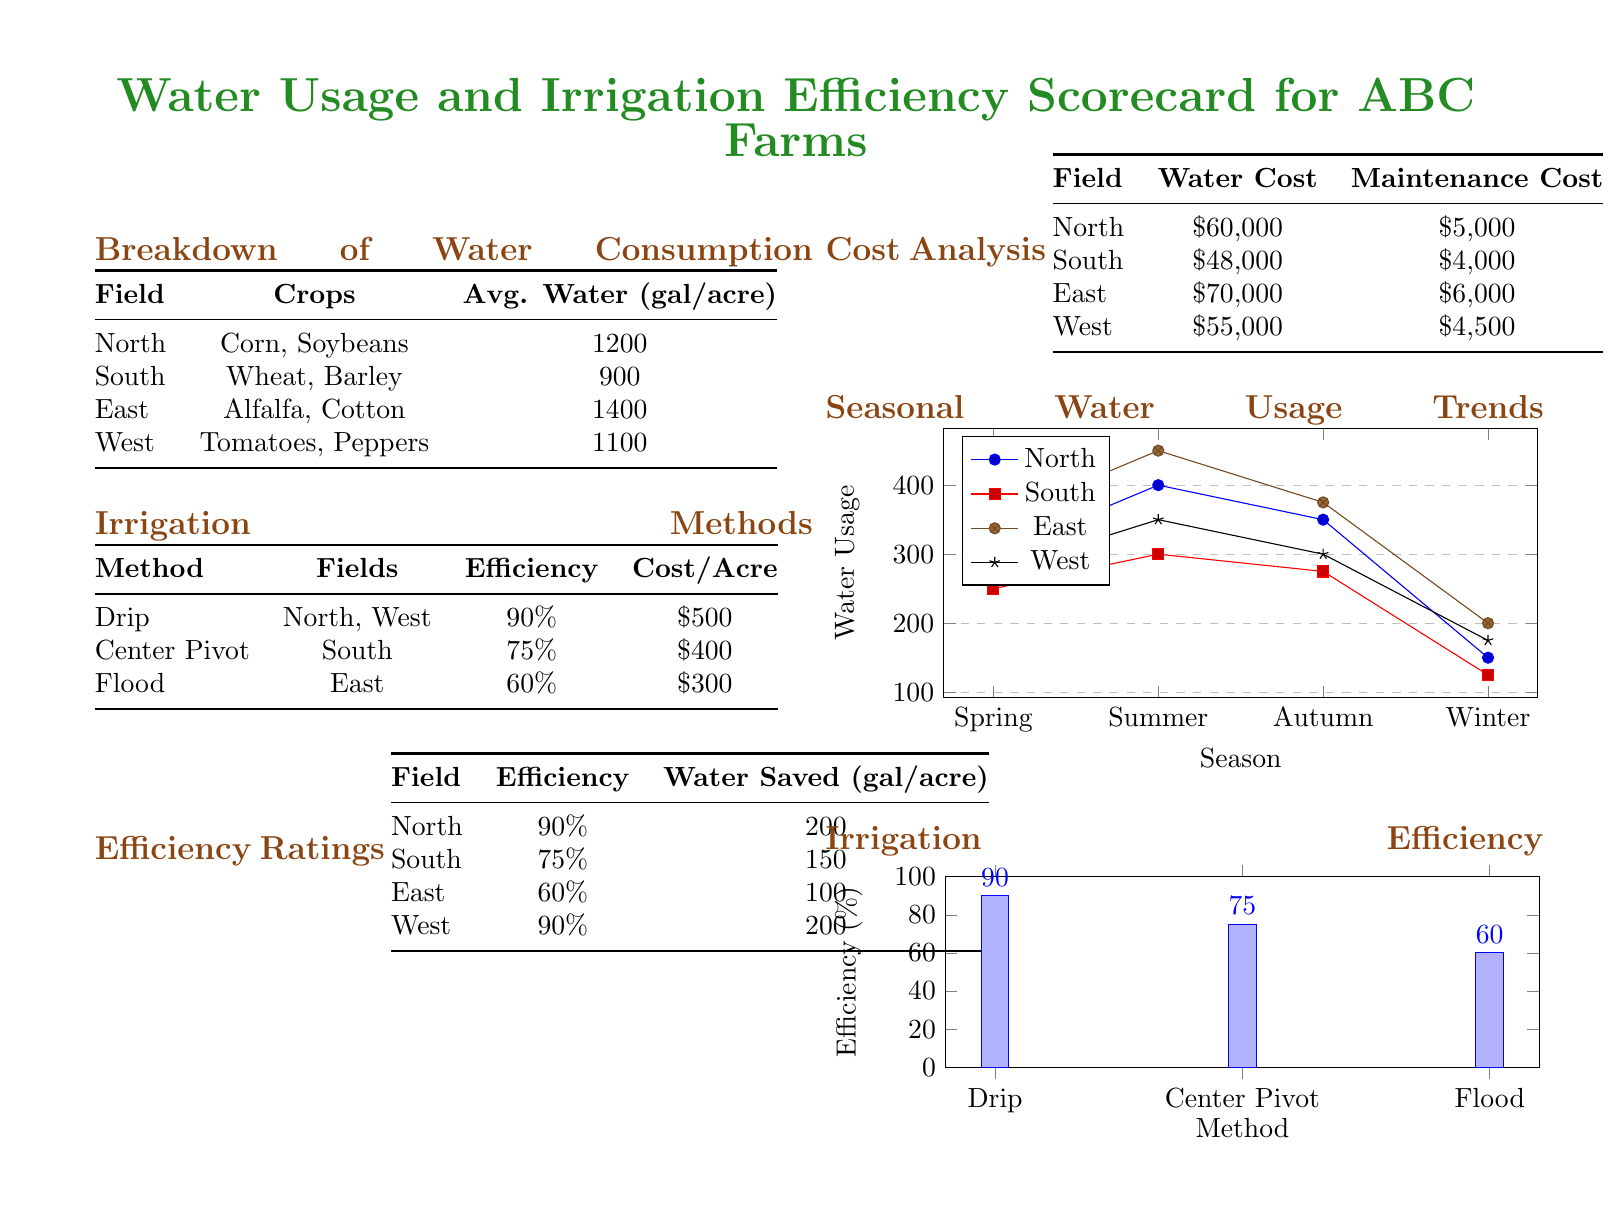What is the average water consumption for the East field? The average water consumption for the East field is 1400 gallons per acre as stated in the Breakdown of Water Consumption table.
Answer: 1400 gallons per acre Which irrigation method has the highest efficiency rating? The highest efficiency rating among the irrigation methods listed is for Drip, which has an efficiency of 90%.
Answer: Drip How much water is saved per acre in the South field? The South field saves 150 gallons per acre according to the Efficiency Ratings table.
Answer: 150 gallons per acre What is the total water cost for the North field? The total water cost for the North field is found in the Cost Analysis table, which states it is $60,000.
Answer: $60,000 Which crop is grown in the South field? The crops grown in the South field are Wheat and Barley as mentioned in the Breakdown of Water Consumption.
Answer: Wheat, Barley How much does it cost to maintain irrigation per acre in the East field? The maintenance cost per acre in the East field is $6,000, as shown in the Cost Analysis section.
Answer: $6,000 What was the water usage in summer for the West field? The water usage in summer for the West field is 350 gallons as indicated in the Seasonal Water Usage Trends graph.
Answer: 350 gallons What percentage of efficiency does the Flood irrigation method have? The Flood irrigation method has an efficiency rating of 60%, according to the Irrigation Methods table.
Answer: 60% Which field has the lowest average water consumption? The field with the lowest average water consumption is the South field, which uses 900 gallons per acre according to the Breakdown of Water Consumption table.
Answer: South field 